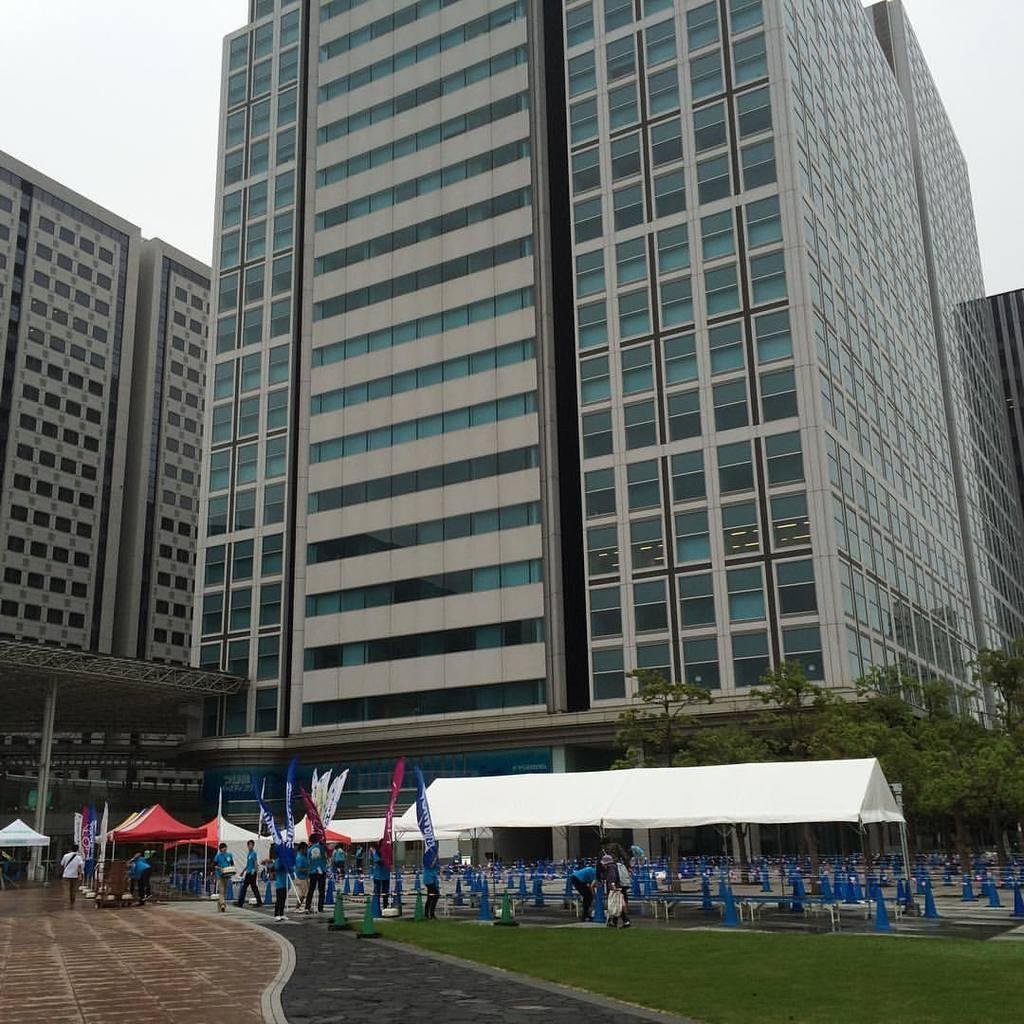What type of structures can be seen in the image? There are buildings in the image. What type of vegetation is present in the image? There are trees and grass in the image. What type of seating is available in the image? There are benches in the image. Who or what is present in the image? There are people in the image. What type of decorations or symbols are visible in the image? There are flags in the image. What type of temporary shelters are visible in the image? There are tents in the image. What can be seen at the top of the image? The sky is visible at the top of the image. How many kittens are playing with the debt in the image? There are no kittens or debt present in the image. What type of respect is shown by the people in the image? The image does not depict any specific type of respect; it simply shows people in a particular setting. 